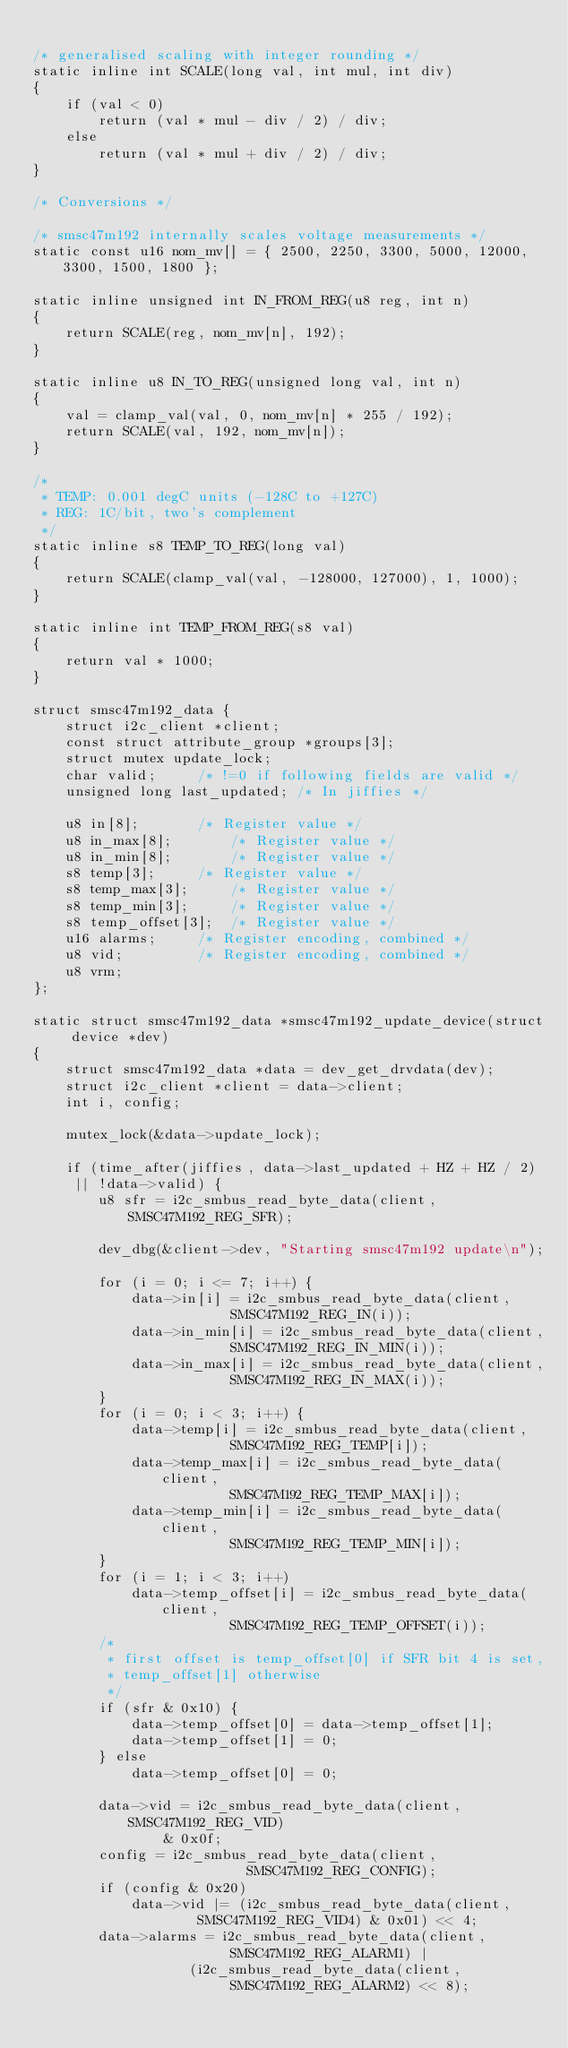<code> <loc_0><loc_0><loc_500><loc_500><_C_>
/* generalised scaling with integer rounding */
static inline int SCALE(long val, int mul, int div)
{
	if (val < 0)
		return (val * mul - div / 2) / div;
	else
		return (val * mul + div / 2) / div;
}

/* Conversions */

/* smsc47m192 internally scales voltage measurements */
static const u16 nom_mv[] = { 2500, 2250, 3300, 5000, 12000, 3300, 1500, 1800 };

static inline unsigned int IN_FROM_REG(u8 reg, int n)
{
	return SCALE(reg, nom_mv[n], 192);
}

static inline u8 IN_TO_REG(unsigned long val, int n)
{
	val = clamp_val(val, 0, nom_mv[n] * 255 / 192);
	return SCALE(val, 192, nom_mv[n]);
}

/*
 * TEMP: 0.001 degC units (-128C to +127C)
 * REG: 1C/bit, two's complement
 */
static inline s8 TEMP_TO_REG(long val)
{
	return SCALE(clamp_val(val, -128000, 127000), 1, 1000);
}

static inline int TEMP_FROM_REG(s8 val)
{
	return val * 1000;
}

struct smsc47m192_data {
	struct i2c_client *client;
	const struct attribute_group *groups[3];
	struct mutex update_lock;
	char valid;		/* !=0 if following fields are valid */
	unsigned long last_updated;	/* In jiffies */

	u8 in[8];		/* Register value */
	u8 in_max[8];		/* Register value */
	u8 in_min[8];		/* Register value */
	s8 temp[3];		/* Register value */
	s8 temp_max[3];		/* Register value */
	s8 temp_min[3];		/* Register value */
	s8 temp_offset[3];	/* Register value */
	u16 alarms;		/* Register encoding, combined */
	u8 vid;			/* Register encoding, combined */
	u8 vrm;
};

static struct smsc47m192_data *smsc47m192_update_device(struct device *dev)
{
	struct smsc47m192_data *data = dev_get_drvdata(dev);
	struct i2c_client *client = data->client;
	int i, config;

	mutex_lock(&data->update_lock);

	if (time_after(jiffies, data->last_updated + HZ + HZ / 2)
	 || !data->valid) {
		u8 sfr = i2c_smbus_read_byte_data(client, SMSC47M192_REG_SFR);

		dev_dbg(&client->dev, "Starting smsc47m192 update\n");

		for (i = 0; i <= 7; i++) {
			data->in[i] = i2c_smbus_read_byte_data(client,
						SMSC47M192_REG_IN(i));
			data->in_min[i] = i2c_smbus_read_byte_data(client,
						SMSC47M192_REG_IN_MIN(i));
			data->in_max[i] = i2c_smbus_read_byte_data(client,
						SMSC47M192_REG_IN_MAX(i));
		}
		for (i = 0; i < 3; i++) {
			data->temp[i] = i2c_smbus_read_byte_data(client,
						SMSC47M192_REG_TEMP[i]);
			data->temp_max[i] = i2c_smbus_read_byte_data(client,
						SMSC47M192_REG_TEMP_MAX[i]);
			data->temp_min[i] = i2c_smbus_read_byte_data(client,
						SMSC47M192_REG_TEMP_MIN[i]);
		}
		for (i = 1; i < 3; i++)
			data->temp_offset[i] = i2c_smbus_read_byte_data(client,
						SMSC47M192_REG_TEMP_OFFSET(i));
		/*
		 * first offset is temp_offset[0] if SFR bit 4 is set,
		 * temp_offset[1] otherwise
		 */
		if (sfr & 0x10) {
			data->temp_offset[0] = data->temp_offset[1];
			data->temp_offset[1] = 0;
		} else
			data->temp_offset[0] = 0;

		data->vid = i2c_smbus_read_byte_data(client, SMSC47M192_REG_VID)
			    & 0x0f;
		config = i2c_smbus_read_byte_data(client,
						  SMSC47M192_REG_CONFIG);
		if (config & 0x20)
			data->vid |= (i2c_smbus_read_byte_data(client,
					SMSC47M192_REG_VID4) & 0x01) << 4;
		data->alarms = i2c_smbus_read_byte_data(client,
						SMSC47M192_REG_ALARM1) |
			       (i2c_smbus_read_byte_data(client,
						SMSC47M192_REG_ALARM2) << 8);
</code> 